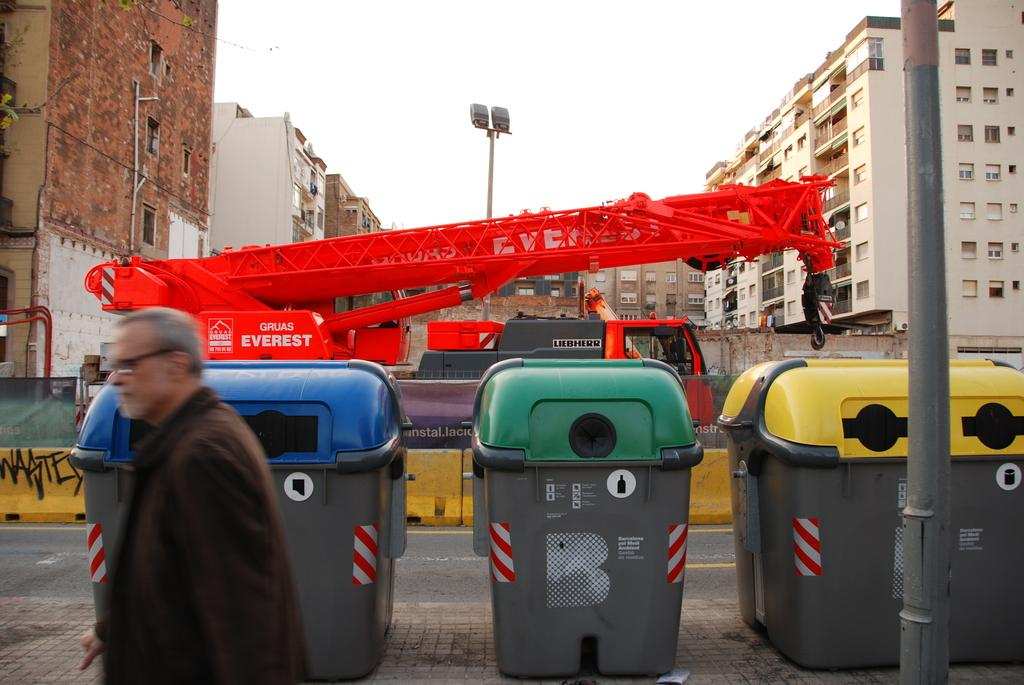<image>
Share a concise interpretation of the image provided. A red crane with the name Graus Everest is positioned behind recycling bins. 